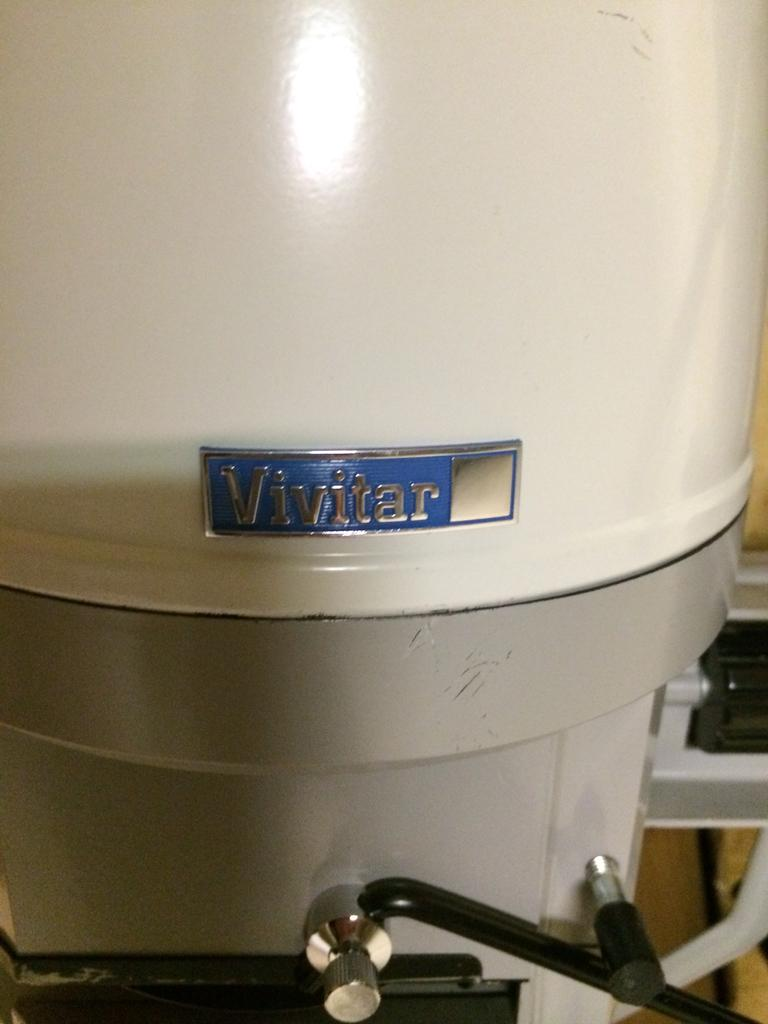Provide a one-sentence caption for the provided image. a white and grey machine with a label that says 'vivitar' on it. 